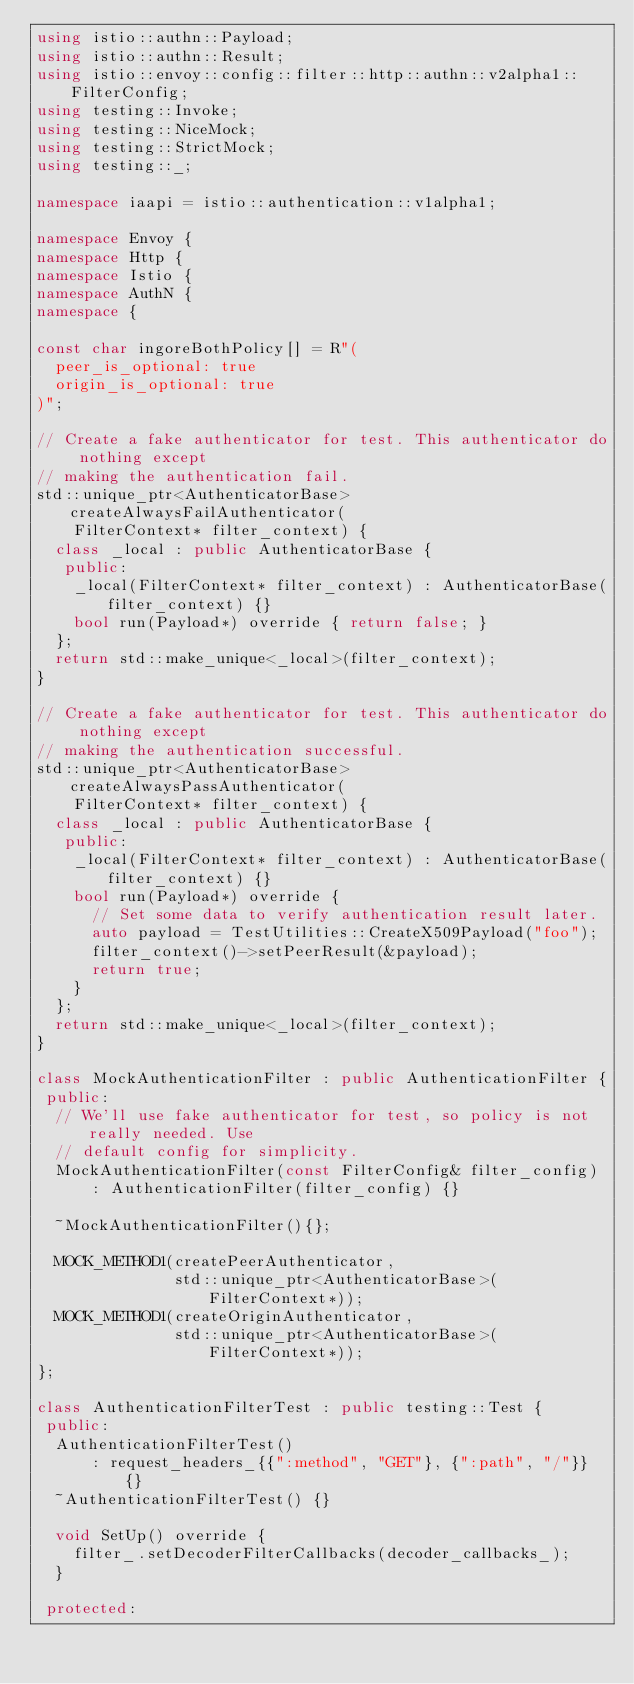Convert code to text. <code><loc_0><loc_0><loc_500><loc_500><_C++_>using istio::authn::Payload;
using istio::authn::Result;
using istio::envoy::config::filter::http::authn::v2alpha1::FilterConfig;
using testing::Invoke;
using testing::NiceMock;
using testing::StrictMock;
using testing::_;

namespace iaapi = istio::authentication::v1alpha1;

namespace Envoy {
namespace Http {
namespace Istio {
namespace AuthN {
namespace {

const char ingoreBothPolicy[] = R"(
  peer_is_optional: true
  origin_is_optional: true
)";

// Create a fake authenticator for test. This authenticator do nothing except
// making the authentication fail.
std::unique_ptr<AuthenticatorBase> createAlwaysFailAuthenticator(
    FilterContext* filter_context) {
  class _local : public AuthenticatorBase {
   public:
    _local(FilterContext* filter_context) : AuthenticatorBase(filter_context) {}
    bool run(Payload*) override { return false; }
  };
  return std::make_unique<_local>(filter_context);
}

// Create a fake authenticator for test. This authenticator do nothing except
// making the authentication successful.
std::unique_ptr<AuthenticatorBase> createAlwaysPassAuthenticator(
    FilterContext* filter_context) {
  class _local : public AuthenticatorBase {
   public:
    _local(FilterContext* filter_context) : AuthenticatorBase(filter_context) {}
    bool run(Payload*) override {
      // Set some data to verify authentication result later.
      auto payload = TestUtilities::CreateX509Payload("foo");
      filter_context()->setPeerResult(&payload);
      return true;
    }
  };
  return std::make_unique<_local>(filter_context);
}

class MockAuthenticationFilter : public AuthenticationFilter {
 public:
  // We'll use fake authenticator for test, so policy is not really needed. Use
  // default config for simplicity.
  MockAuthenticationFilter(const FilterConfig& filter_config)
      : AuthenticationFilter(filter_config) {}

  ~MockAuthenticationFilter(){};

  MOCK_METHOD1(createPeerAuthenticator,
               std::unique_ptr<AuthenticatorBase>(FilterContext*));
  MOCK_METHOD1(createOriginAuthenticator,
               std::unique_ptr<AuthenticatorBase>(FilterContext*));
};

class AuthenticationFilterTest : public testing::Test {
 public:
  AuthenticationFilterTest()
      : request_headers_{{":method", "GET"}, {":path", "/"}} {}
  ~AuthenticationFilterTest() {}

  void SetUp() override {
    filter_.setDecoderFilterCallbacks(decoder_callbacks_);
  }

 protected:</code> 